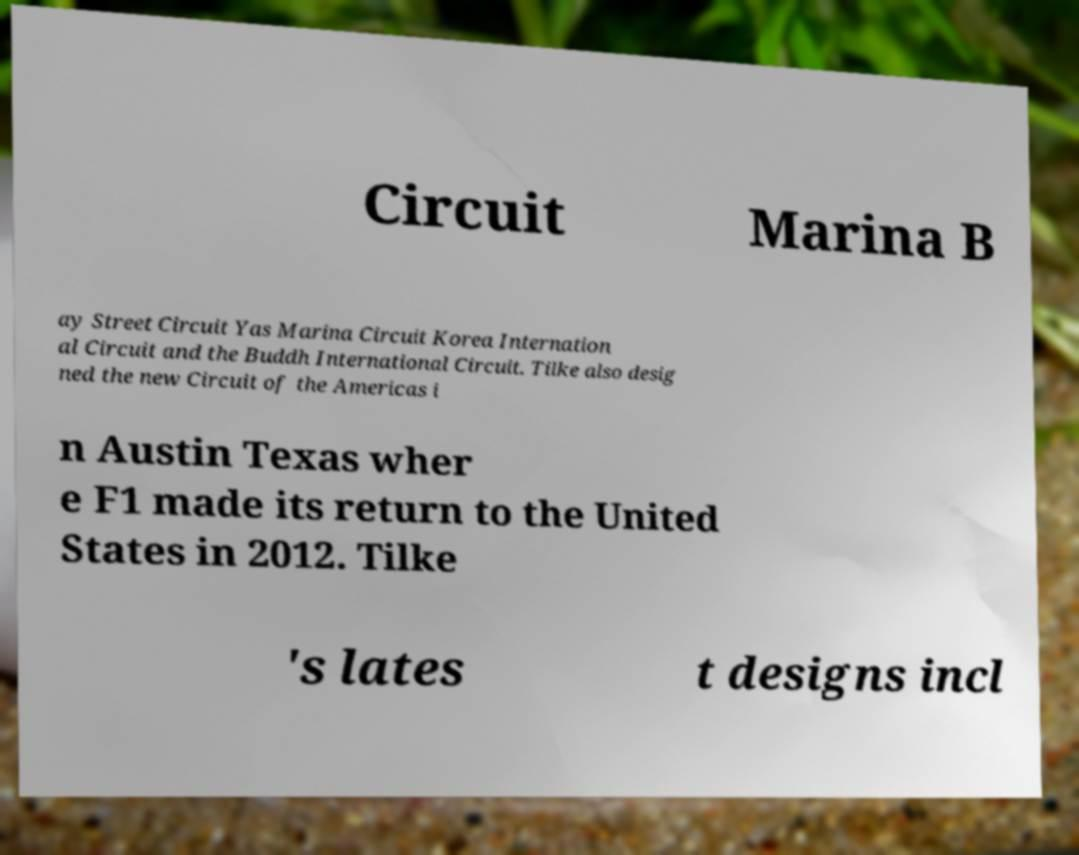There's text embedded in this image that I need extracted. Can you transcribe it verbatim? Circuit Marina B ay Street Circuit Yas Marina Circuit Korea Internation al Circuit and the Buddh International Circuit. Tilke also desig ned the new Circuit of the Americas i n Austin Texas wher e F1 made its return to the United States in 2012. Tilke 's lates t designs incl 